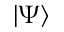Convert formula to latex. <formula><loc_0><loc_0><loc_500><loc_500>| \Psi \rangle</formula> 